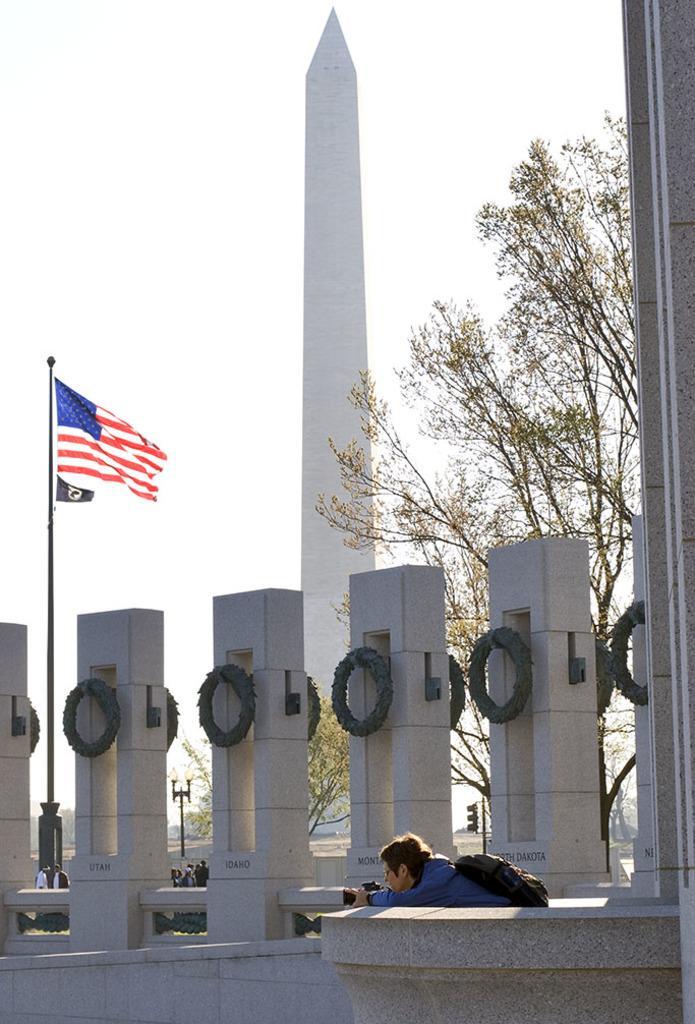How would you summarize this image in a sentence or two? In the image we can see a person wearing clothes and holding a camera in hand, and carrying bag. Here we can see the flag of the country. We can see the tower, trees and the sky. There are even other people wearing clothes. 